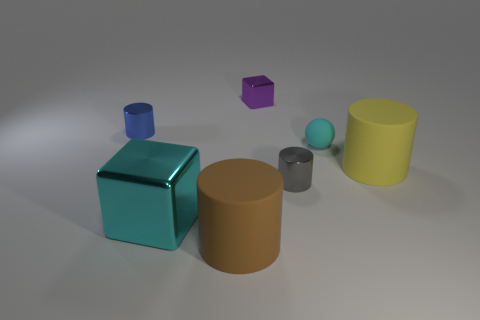Subtract all big yellow matte cylinders. How many cylinders are left? 3 Add 3 red metal spheres. How many objects exist? 10 Subtract all gray cylinders. How many cylinders are left? 3 Subtract all cubes. How many objects are left? 5 Add 7 shiny cubes. How many shiny cubes exist? 9 Subtract 1 yellow cylinders. How many objects are left? 6 Subtract 1 blocks. How many blocks are left? 1 Subtract all yellow balls. Subtract all yellow cylinders. How many balls are left? 1 Subtract all red blocks. How many gray cylinders are left? 1 Subtract all blocks. Subtract all yellow rubber cylinders. How many objects are left? 4 